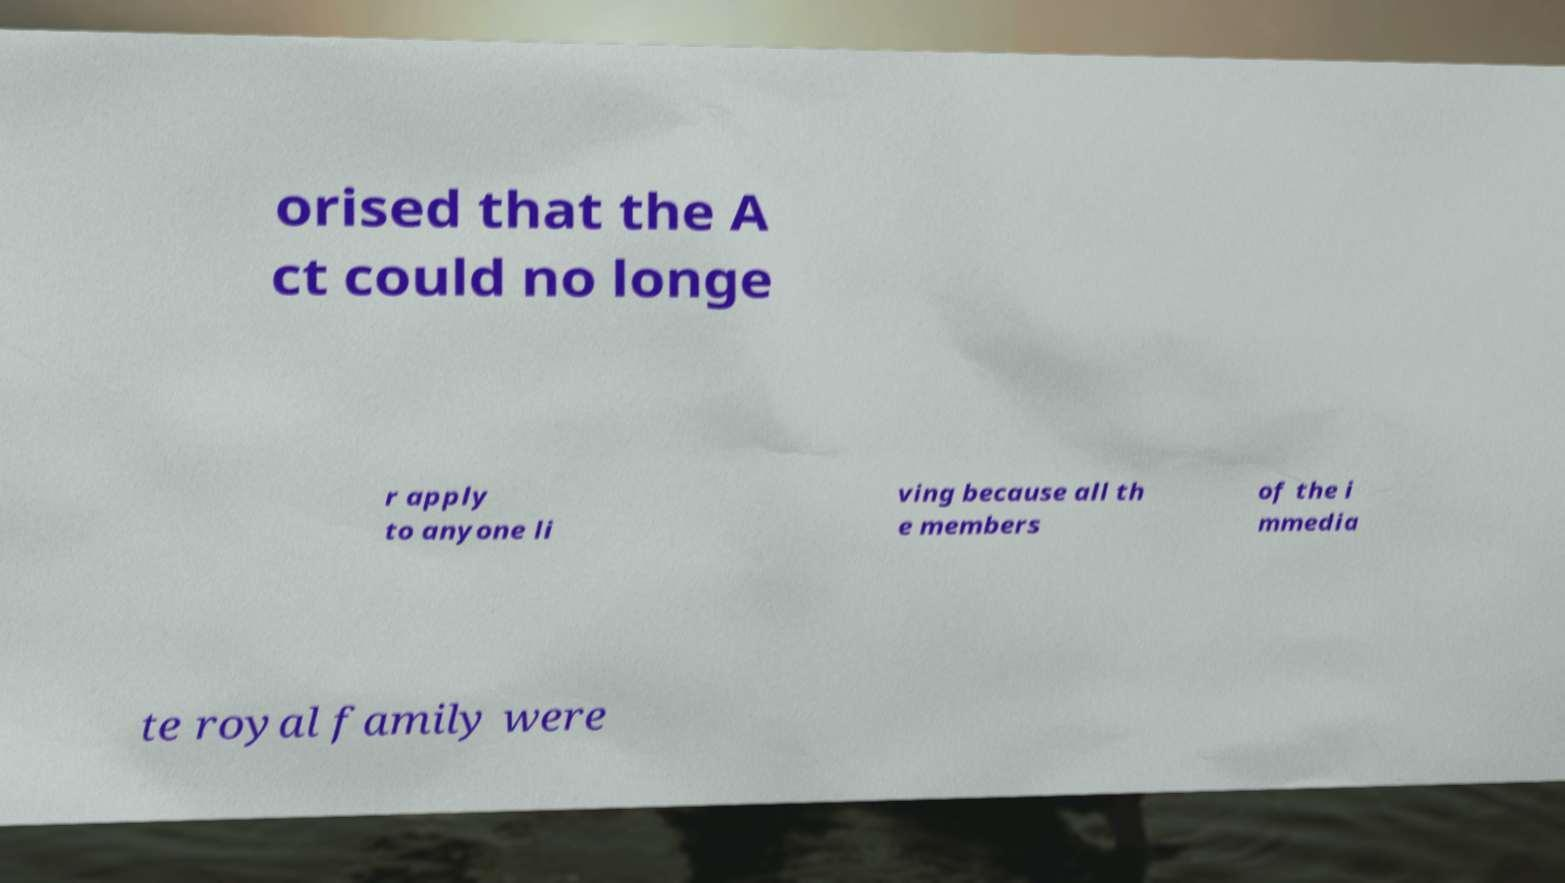Could you extract and type out the text from this image? orised that the A ct could no longe r apply to anyone li ving because all th e members of the i mmedia te royal family were 